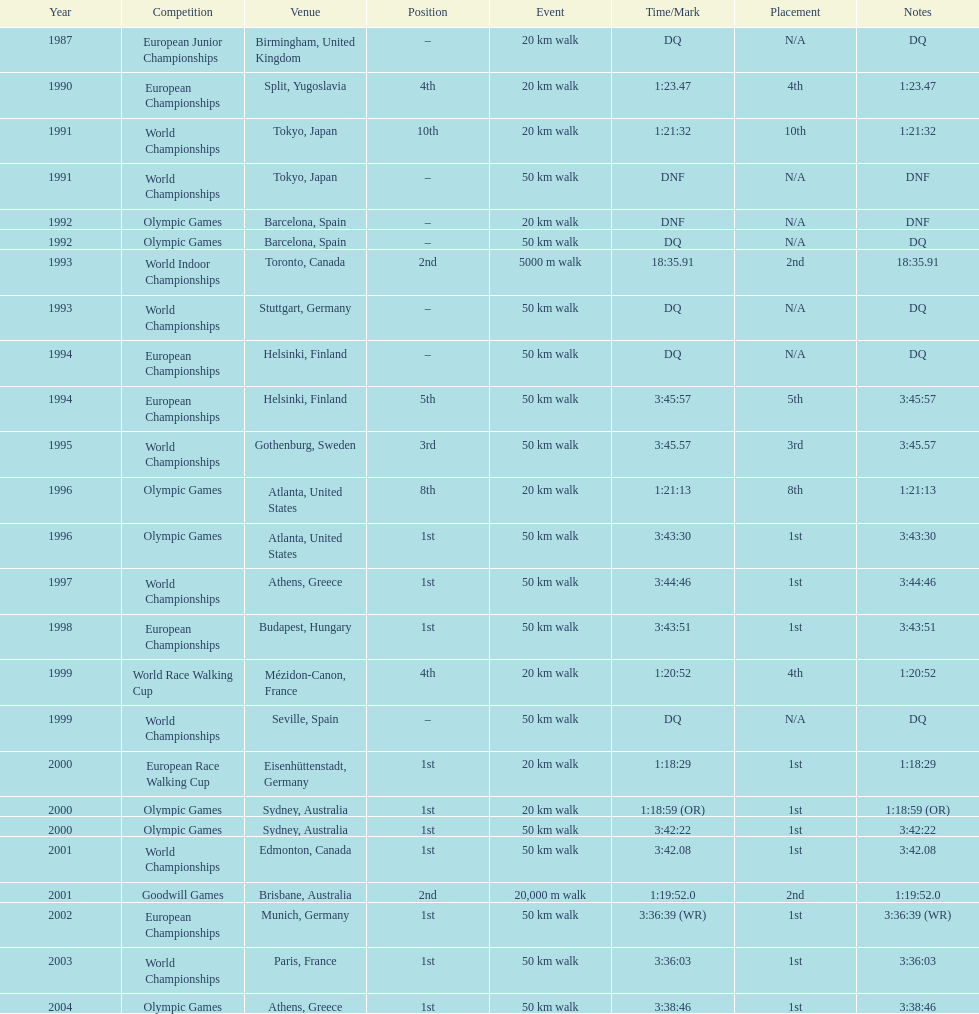How many events had a minimum distance of 50 km? 17. 